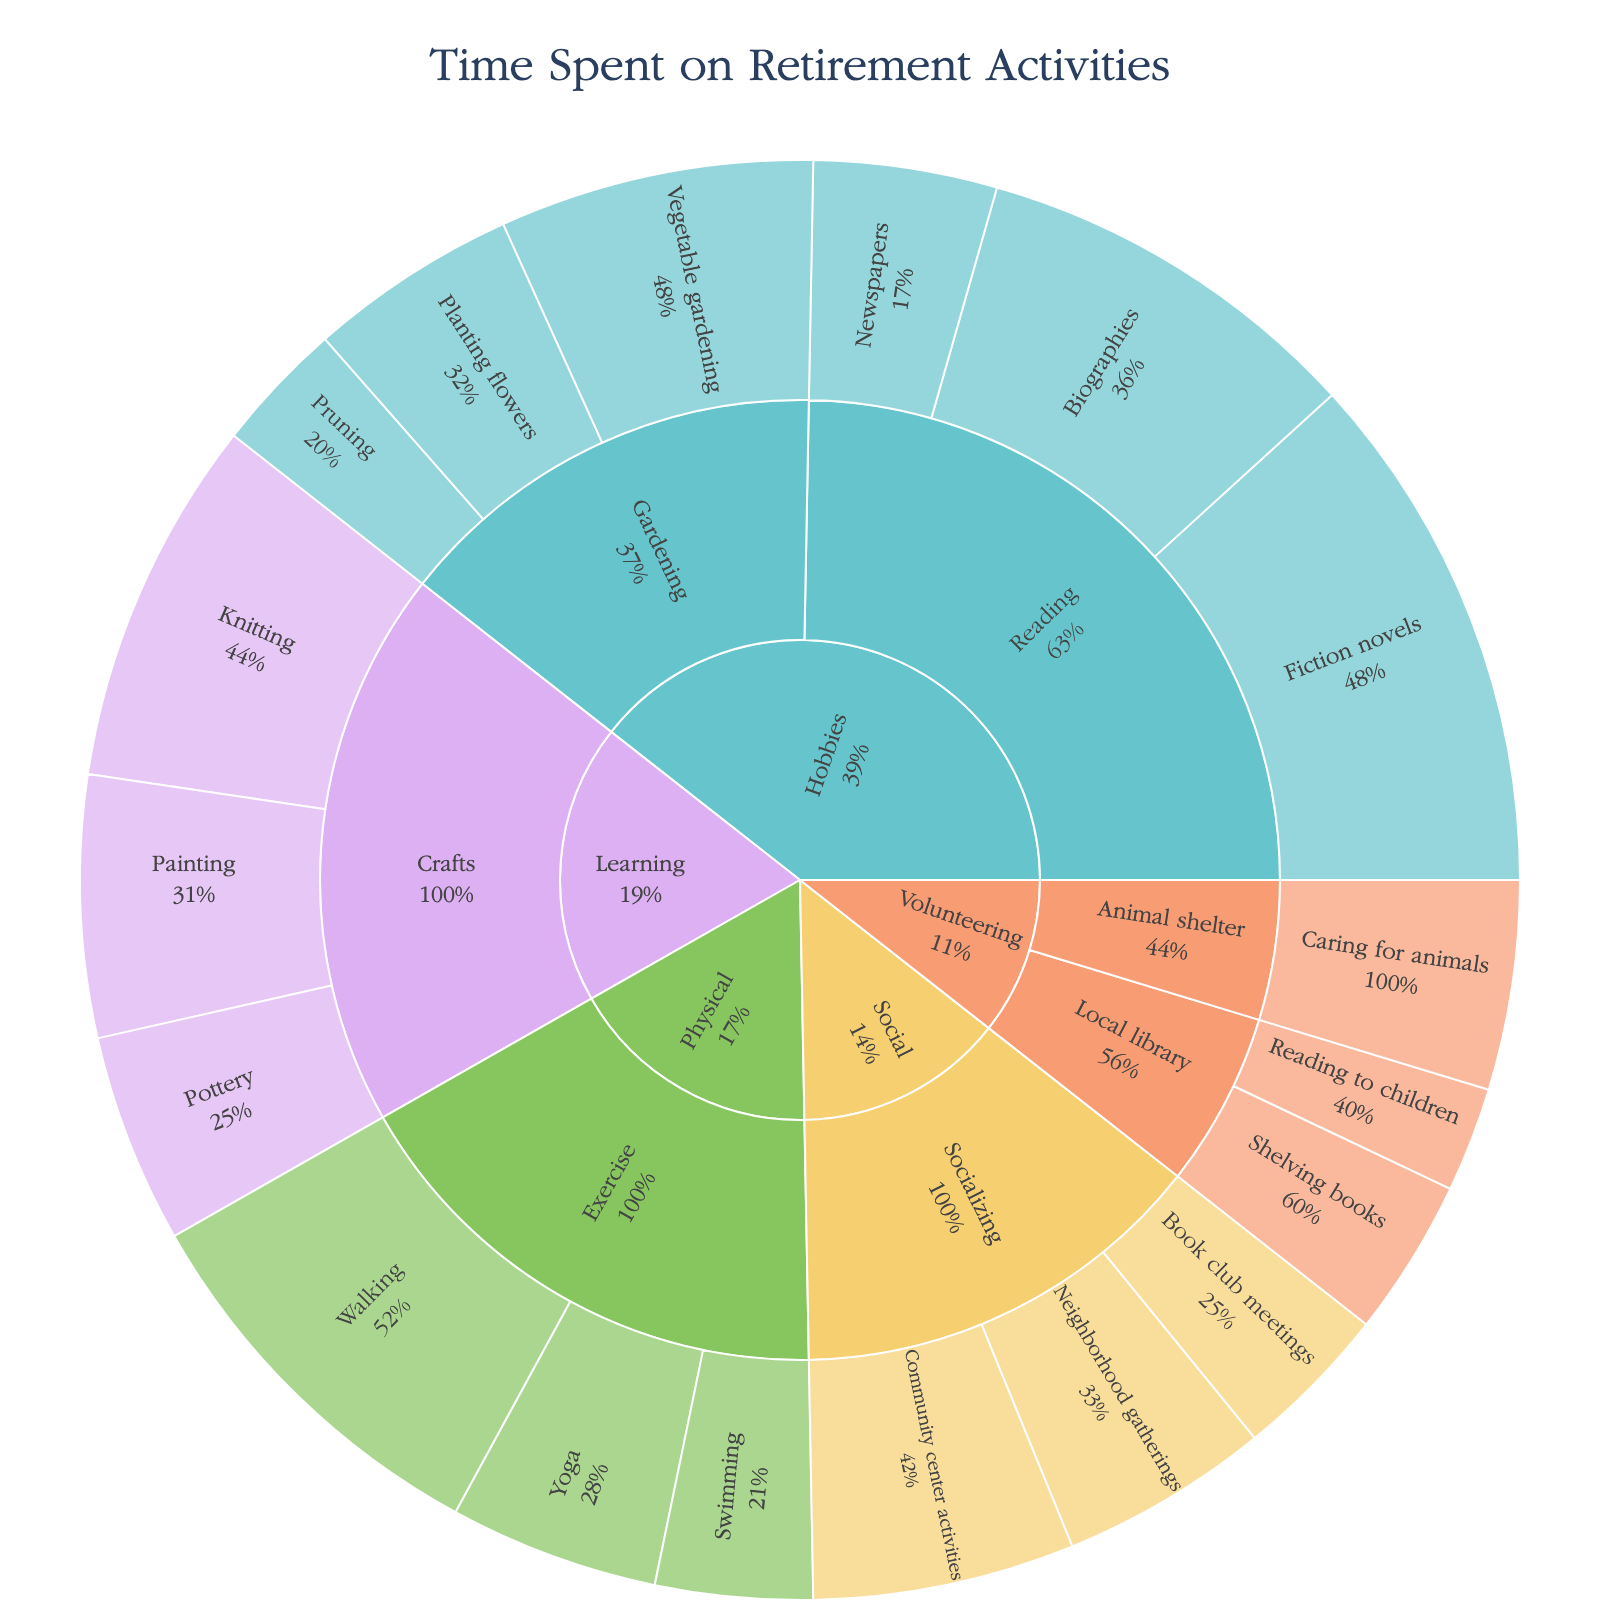what is the title of the figure? The title is located at the top of the figure, clearly stating what the plot represents.
Answer: Time Spent on Retirement Activities how much time is spent on vegetable gardening? The activity "Vegetable gardening" is a subcategory under "Gardening" in the "Hobbies" category. The corresponding value shown is 12 hours.
Answer: 12 hours which activity takes up the most time in the "Socializing" category? Within the "Socializing" subcategory in the "Social" category, look for the activity with the highest hours. "Community center activities" has 10 hours, more than the other activities.
Answer: Community center activities compare the time spent on knitting with painting Knitting and Painting both fall under "Learning" and "Crafts" categories. Knitting has 14 hours, while Painting has 10 hours. Knitting has more hours.
Answer: Knitting is greater what activity has the least amount of time in "Exercise"? Locate the "Exercise" subcategory under "Physical." Out of the activities "Walking," "Yoga," and "Swimming," Swimming has the least time at 6 hours.
Answer: Swimming how many total hours are dedicated to socializing? Add the hours for "Community center activities" (10), "Book club meetings" (6), and "Neighborhood gatherings" (8). Total = 10 + 6 + 8 = 24 hours
Answer: 24 hours how does the time for fiction novels compare to biographies? Both "Fiction novels" and "Biographies" are subcategories under "Reading" in "Hobbies." Fiction novels have 20 hours, and Biographies have 15 hours. Fiction novels take more time.
Answer: Fiction novels is greater which category has the most diverse activities in terms of subcategories and activities? The categories are "Hobbies," "Social," "Learning," "Physical," and "Volunteering." "Hobbies" contains the most subcategories and activities: Gardening (3 activities) and Reading (3 activities).
Answer: Hobbies what is the combined time for activities under the "Gardening" subcategory? The "Gardening" subcategory in "Hobbies" includes "Planting flowers" (8 hours), "Vegetable gardening" (12 hours), and "Pruning" (5 hours). Total = 8 + 12 + 5 = 25 hours.
Answer: 25 hours what percentage of total hours spent does "Yoga" represent within its parent category? Look at the "Exercise" subcategory under "Physical." Yoga has 8 hours, and the total for Exercise (Walking, Yoga, Swimming) is 15 + 8 + 6 = 29. Percentage is (8/29) * 100 ≈ 27.6%.
Answer: 27.6% 